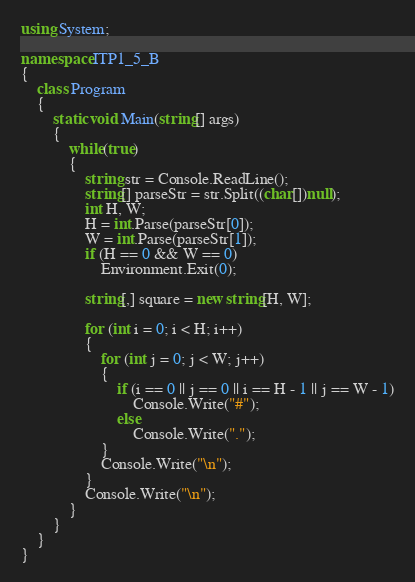<code> <loc_0><loc_0><loc_500><loc_500><_C#_>using System;

namespace ITP1_5_B
{
    class Program
    {
        static void Main(string[] args)
        {
            while(true)
            {
                string str = Console.ReadLine();
                string[] parseStr = str.Split((char[])null);
                int H, W;
                H = int.Parse(parseStr[0]);
                W = int.Parse(parseStr[1]);
                if (H == 0 && W == 0)
                    Environment.Exit(0);

                string[,] square = new string[H, W];

                for (int i = 0; i < H; i++)
                {              
                    for (int j = 0; j < W; j++)
                    {
                        if (i == 0 || j == 0 || i == H - 1 || j == W - 1)
                            Console.Write("#");
                        else
                            Console.Write(".");
                    }
                    Console.Write("\n");
                }
                Console.Write("\n");
            }
        }
    }
}
</code> 